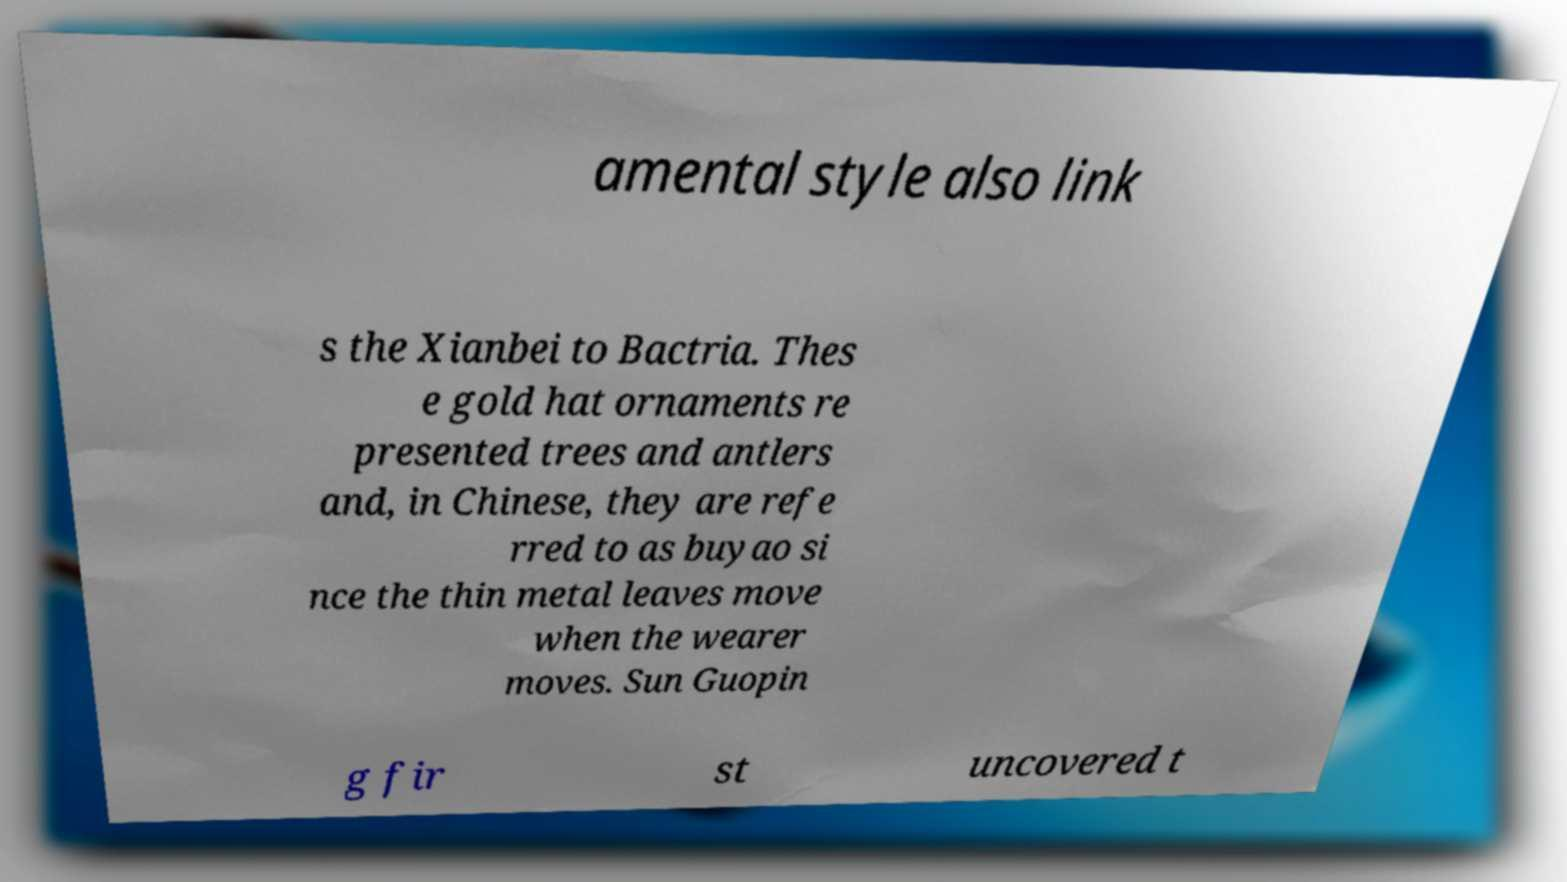Please read and relay the text visible in this image. What does it say? amental style also link s the Xianbei to Bactria. Thes e gold hat ornaments re presented trees and antlers and, in Chinese, they are refe rred to as buyao si nce the thin metal leaves move when the wearer moves. Sun Guopin g fir st uncovered t 